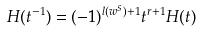<formula> <loc_0><loc_0><loc_500><loc_500>H ( t ^ { - 1 } ) = ( - 1 ) ^ { l ( w ^ { S } ) + 1 } t ^ { r + 1 } H ( t )</formula> 